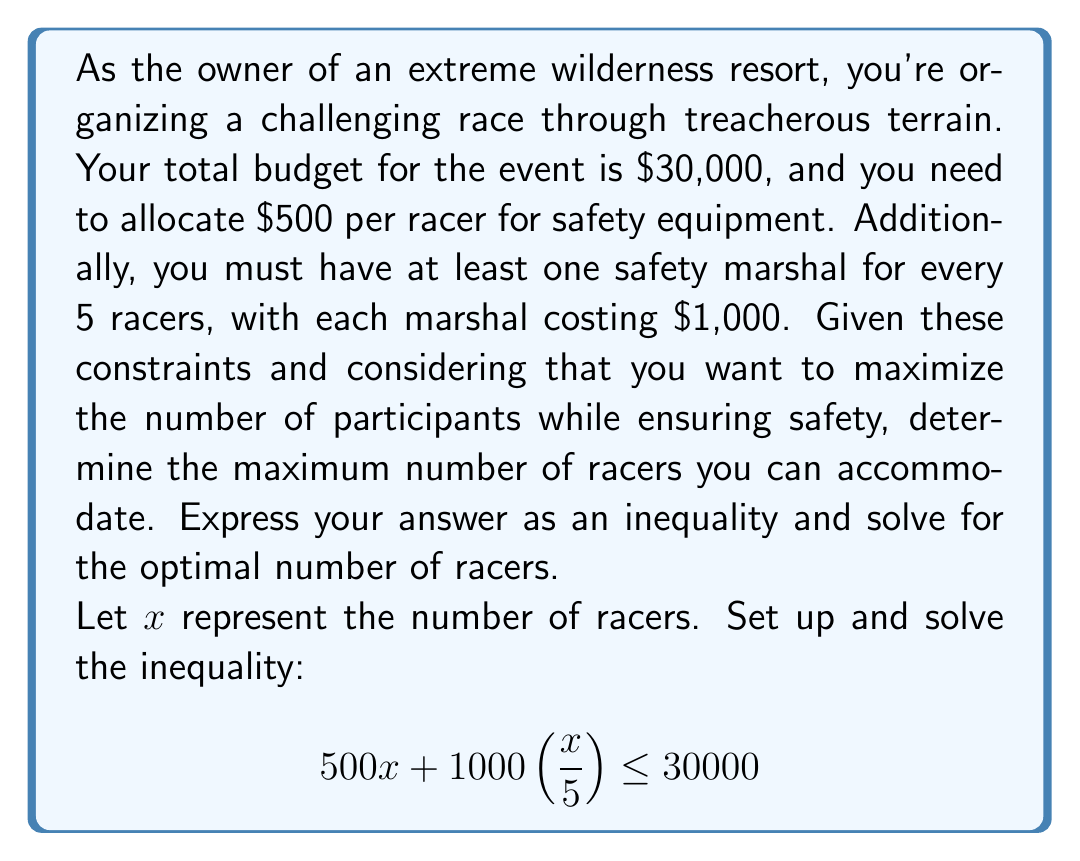Can you solve this math problem? Let's break down the problem and solve it step-by-step:

1) First, let's understand what each part of the inequality represents:
   - $500x$ is the cost for safety equipment for all racers
   - $1000(\frac{x}{5})$ is the cost for safety marshals

2) Now, let's simplify the left side of the inequality:
   $$500x + 1000(\frac{x}{5}) \leq 30000$$
   $$500x + 200x \leq 30000$$
   $$700x \leq 30000$$

3) To solve for $x$, divide both sides by 700:
   $$x \leq \frac{30000}{700}$$
   $$x \leq 42.857...$$

4) Since $x$ represents the number of racers, it must be a whole number. Therefore, we round down to the nearest integer:
   $$x \leq 42$$

5) To verify, let's check if 42 racers satisfy the original constraint:
   $$500(42) + 1000(\frac{42}{5}) = 21000 + 8400 = 29400$$
   This is indeed less than or equal to 30000.

6) If we try 43 racers:
   $$500(43) + 1000(\frac{43}{5}) = 21500 + 8600 = 30100$$
   This exceeds the budget of 30000.

Therefore, the maximum number of racers that can be accommodated is 42.
Answer: The optimal number of racers is 42, satisfying the inequality $x \leq 42$. 